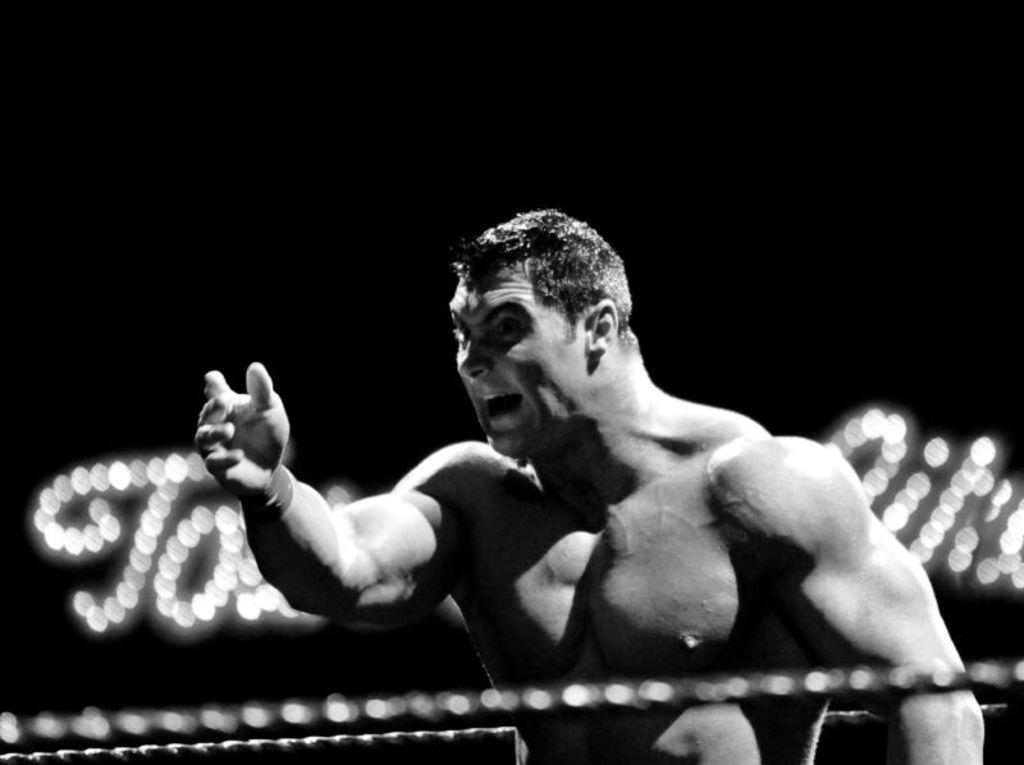Can you describe this image briefly? In this image we can see a black and white picture of a person. In the background, we can see ropes and some lights. 